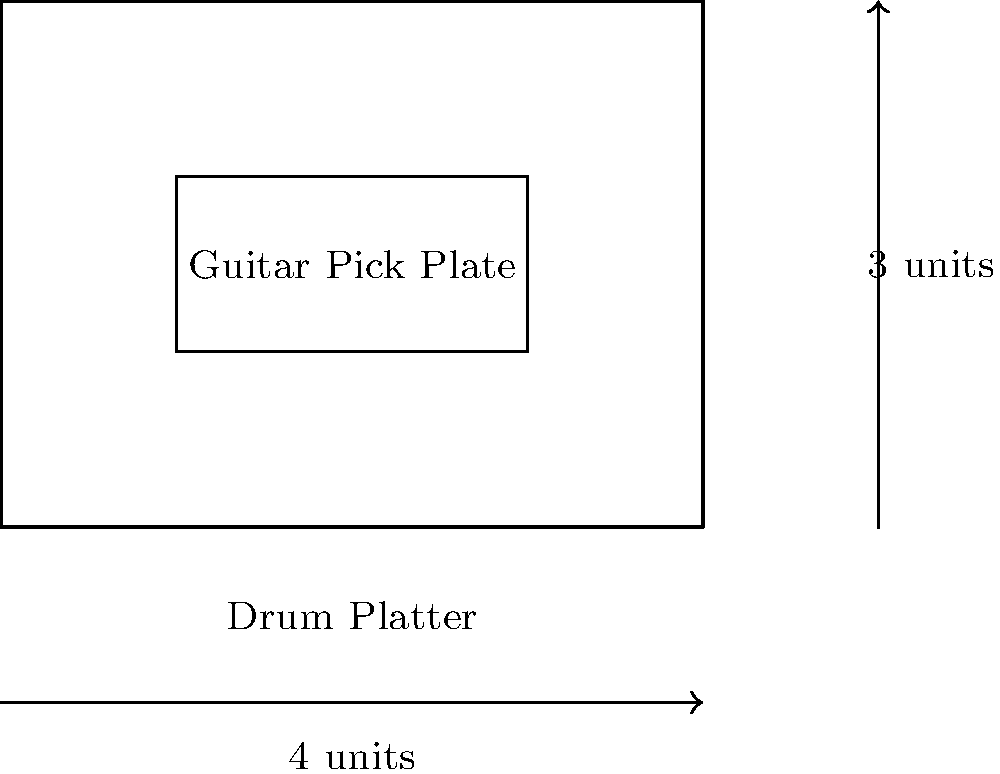In your rockstar-inspired menu, you're designing two congruent food presentation layouts: a "Guitar Pick Plate" and a "Drum Platter". The Drum Platter is rectangular with dimensions 4 units by 3 units. The Guitar Pick Plate is represented by the inner rectangle. If the Guitar Pick Plate has a width that is 2 units less than the Drum Platter, what is the area of the Guitar Pick Plate? Let's approach this step-by-step:

1) We know the Drum Platter is 4 units wide and 3 units long.

2) The Guitar Pick Plate has a width that is 2 units less than the Drum Platter.
   So, its width = 4 - 2 = 2 units

3) Since the shapes are congruent, they must have the same ratio of length to width.
   Let's call the length of the Guitar Pick Plate $x$.

4) We can set up a proportion:
   $$\frac{\text{Drum Platter length}}{\text{Drum Platter width}} = \frac{\text{Guitar Pick Plate length}}{\text{Guitar Pick Plate width}}$$
   
   $$\frac{3}{4} = \frac{x}{2}$$

5) Cross multiply:
   $$3 * 2 = 4x$$
   $$6 = 4x$$

6) Solve for $x$:
   $$x = \frac{6}{4} = 1.5$$

7) Now we know the dimensions of the Guitar Pick Plate: 2 units by 1.5 units

8) The area of a rectangle is length * width
   Area = 2 * 1.5 = 3 square units

Therefore, the area of the Guitar Pick Plate is 3 square units.
Answer: 3 square units 